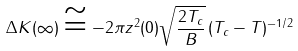<formula> <loc_0><loc_0><loc_500><loc_500>\Delta K ( \infty ) \cong - 2 \pi z ^ { 2 } ( 0 ) \sqrt { \frac { 2 T _ { c } } { B } } \, ( T _ { c } - T ) ^ { - 1 / 2 }</formula> 